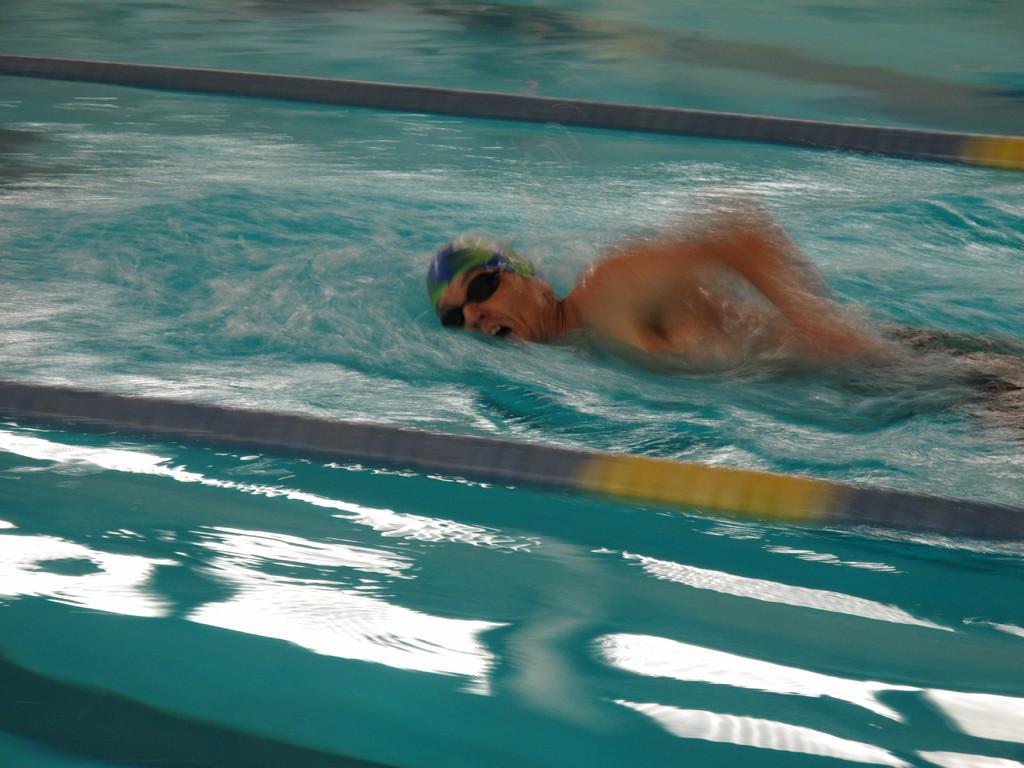Could you give a brief overview of what you see in this image? In the center of the image we can see a man swimming in the water. 